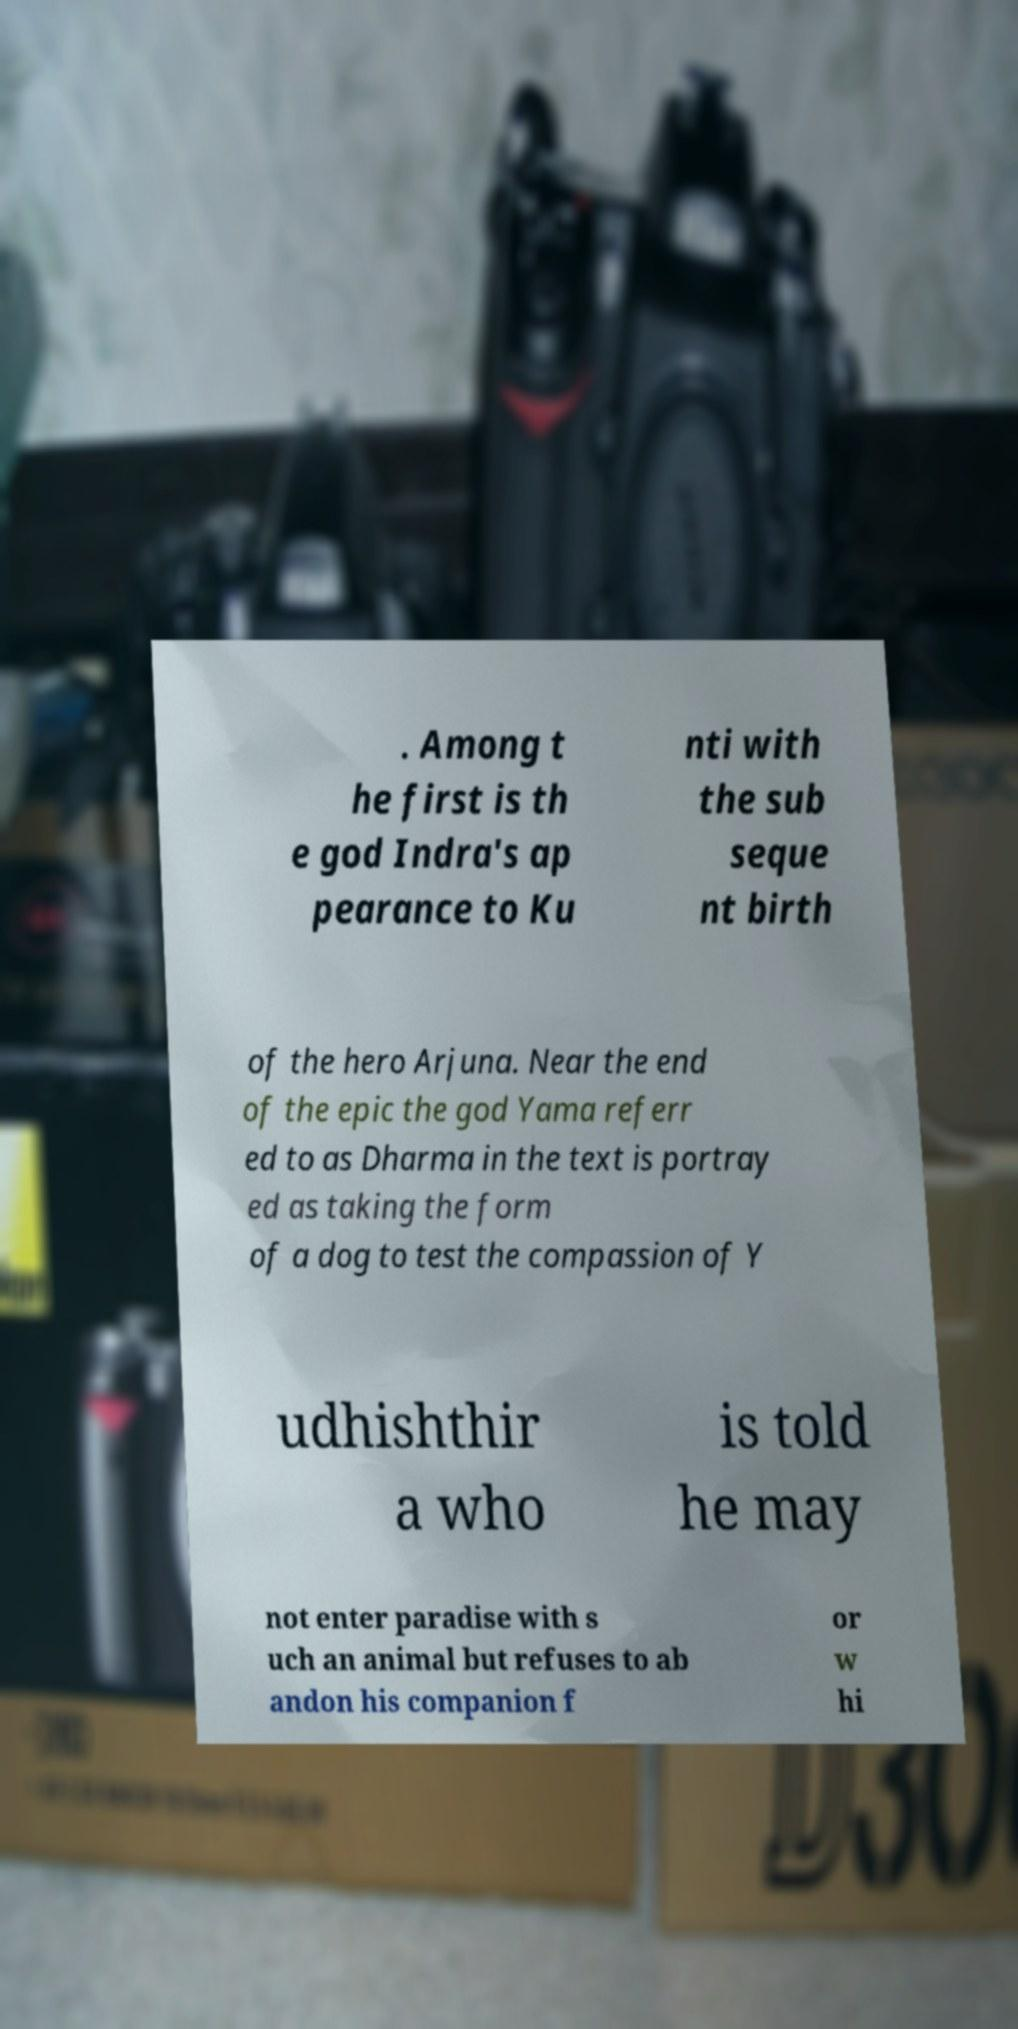Can you accurately transcribe the text from the provided image for me? . Among t he first is th e god Indra's ap pearance to Ku nti with the sub seque nt birth of the hero Arjuna. Near the end of the epic the god Yama referr ed to as Dharma in the text is portray ed as taking the form of a dog to test the compassion of Y udhishthir a who is told he may not enter paradise with s uch an animal but refuses to ab andon his companion f or w hi 